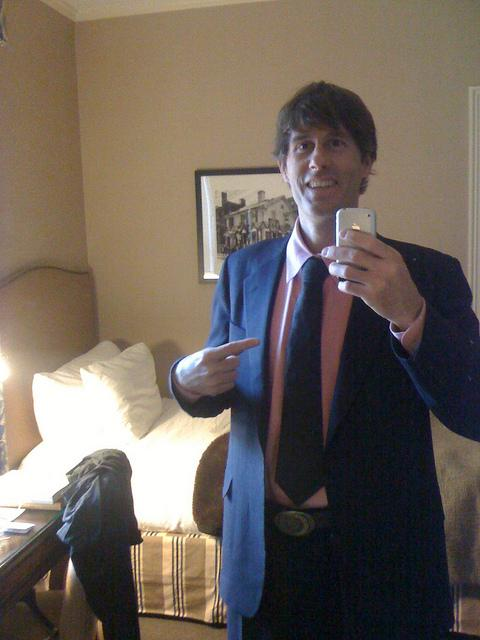What is the man doing? selfie 